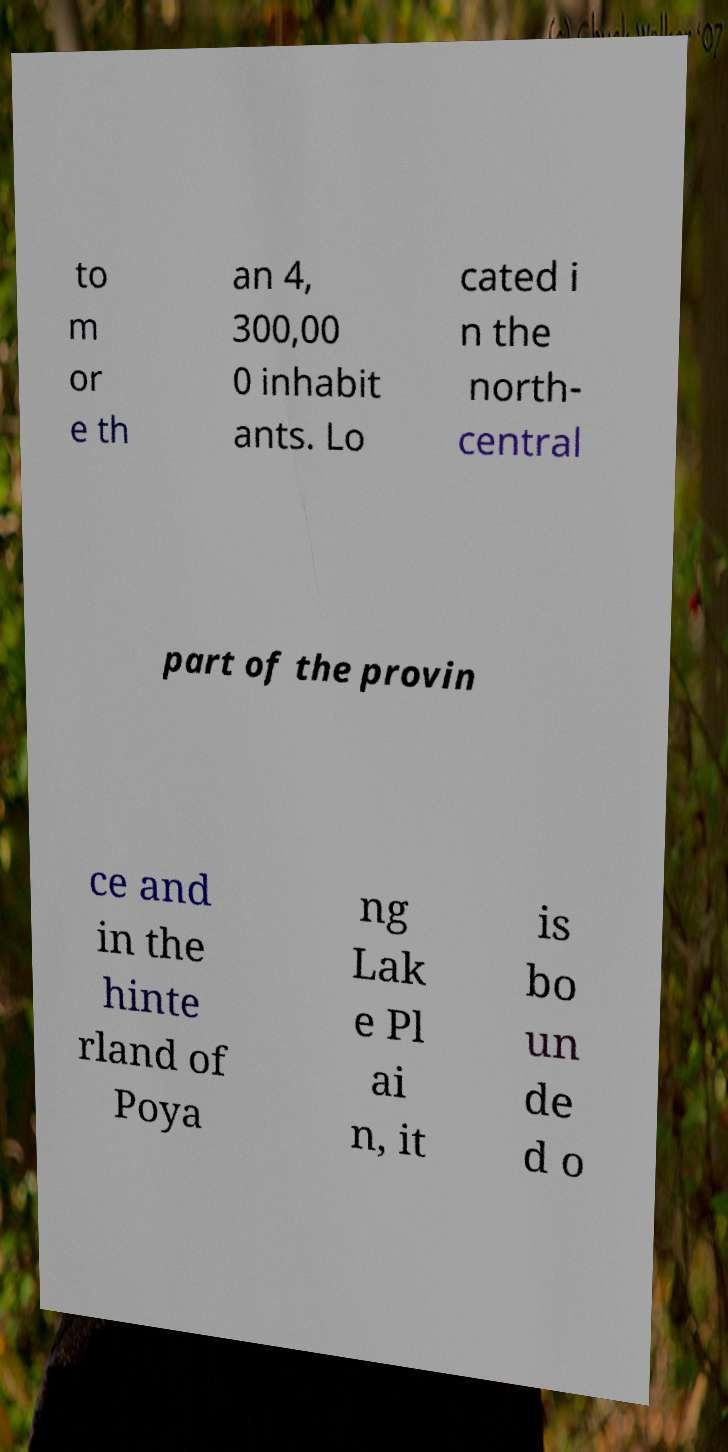What messages or text are displayed in this image? I need them in a readable, typed format. to m or e th an 4, 300,00 0 inhabit ants. Lo cated i n the north- central part of the provin ce and in the hinte rland of Poya ng Lak e Pl ai n, it is bo un de d o 